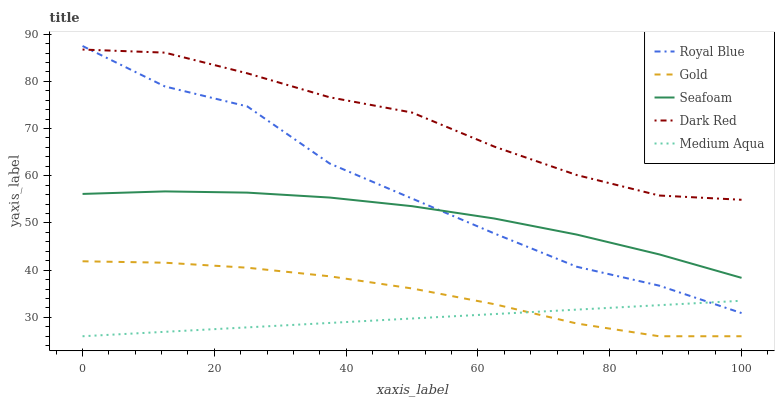Does Medium Aqua have the minimum area under the curve?
Answer yes or no. Yes. Does Dark Red have the maximum area under the curve?
Answer yes or no. Yes. Does Seafoam have the minimum area under the curve?
Answer yes or no. No. Does Seafoam have the maximum area under the curve?
Answer yes or no. No. Is Medium Aqua the smoothest?
Answer yes or no. Yes. Is Royal Blue the roughest?
Answer yes or no. Yes. Is Seafoam the smoothest?
Answer yes or no. No. Is Seafoam the roughest?
Answer yes or no. No. Does Seafoam have the lowest value?
Answer yes or no. No. Does Royal Blue have the highest value?
Answer yes or no. Yes. Does Seafoam have the highest value?
Answer yes or no. No. Is Seafoam less than Dark Red?
Answer yes or no. Yes. Is Royal Blue greater than Gold?
Answer yes or no. Yes. Does Medium Aqua intersect Royal Blue?
Answer yes or no. Yes. Is Medium Aqua less than Royal Blue?
Answer yes or no. No. Is Medium Aqua greater than Royal Blue?
Answer yes or no. No. Does Seafoam intersect Dark Red?
Answer yes or no. No. 